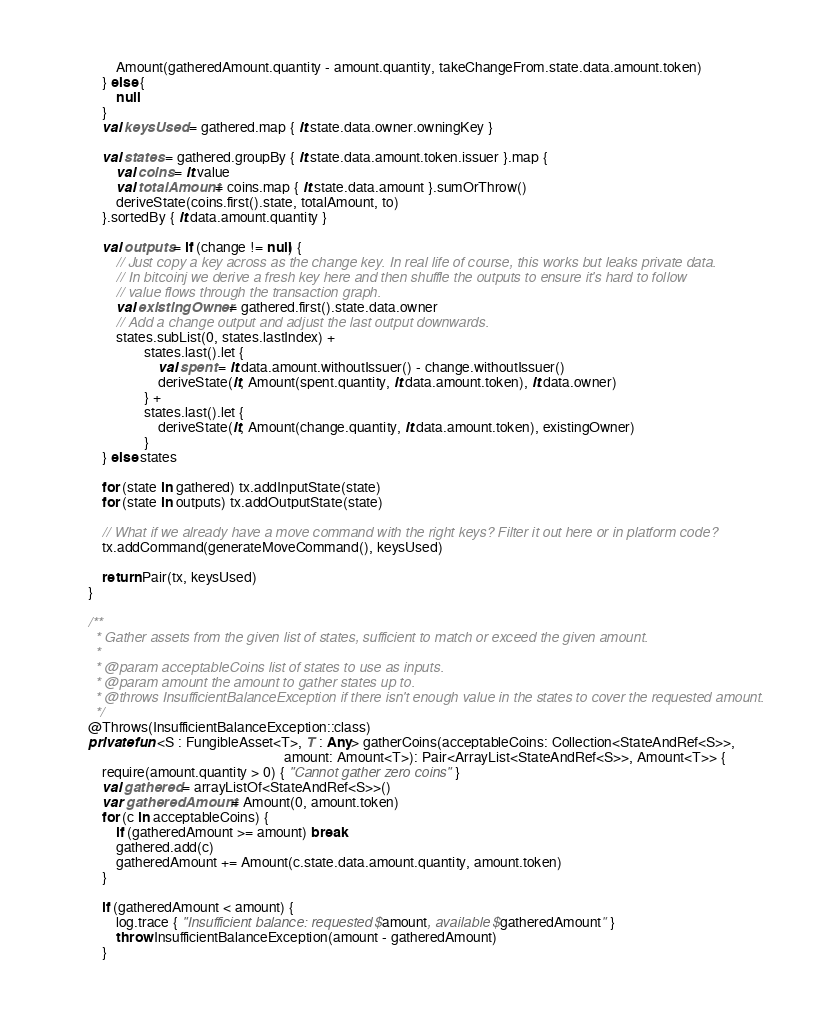<code> <loc_0><loc_0><loc_500><loc_500><_Kotlin_>                Amount(gatheredAmount.quantity - amount.quantity, takeChangeFrom.state.data.amount.token)
            } else {
                null
            }
            val keysUsed = gathered.map { it.state.data.owner.owningKey }

            val states = gathered.groupBy { it.state.data.amount.token.issuer }.map {
                val coins = it.value
                val totalAmount = coins.map { it.state.data.amount }.sumOrThrow()
                deriveState(coins.first().state, totalAmount, to)
            }.sortedBy { it.data.amount.quantity }

            val outputs = if (change != null) {
                // Just copy a key across as the change key. In real life of course, this works but leaks private data.
                // In bitcoinj we derive a fresh key here and then shuffle the outputs to ensure it's hard to follow
                // value flows through the transaction graph.
                val existingOwner = gathered.first().state.data.owner
                // Add a change output and adjust the last output downwards.
                states.subList(0, states.lastIndex) +
                        states.last().let {
                            val spent = it.data.amount.withoutIssuer() - change.withoutIssuer()
                            deriveState(it, Amount(spent.quantity, it.data.amount.token), it.data.owner)
                        } +
                        states.last().let {
                            deriveState(it, Amount(change.quantity, it.data.amount.token), existingOwner)
                        }
            } else states

            for (state in gathered) tx.addInputState(state)
            for (state in outputs) tx.addOutputState(state)

            // What if we already have a move command with the right keys? Filter it out here or in platform code?
            tx.addCommand(generateMoveCommand(), keysUsed)

            return Pair(tx, keysUsed)
        }

        /**
         * Gather assets from the given list of states, sufficient to match or exceed the given amount.
         *
         * @param acceptableCoins list of states to use as inputs.
         * @param amount the amount to gather states up to.
         * @throws InsufficientBalanceException if there isn't enough value in the states to cover the requested amount.
         */
        @Throws(InsufficientBalanceException::class)
        private fun <S : FungibleAsset<T>, T : Any> gatherCoins(acceptableCoins: Collection<StateAndRef<S>>,
                                                                amount: Amount<T>): Pair<ArrayList<StateAndRef<S>>, Amount<T>> {
            require(amount.quantity > 0) { "Cannot gather zero coins" }
            val gathered = arrayListOf<StateAndRef<S>>()
            var gatheredAmount = Amount(0, amount.token)
            for (c in acceptableCoins) {
                if (gatheredAmount >= amount) break
                gathered.add(c)
                gatheredAmount += Amount(c.state.data.amount.quantity, amount.token)
            }

            if (gatheredAmount < amount) {
                log.trace { "Insufficient balance: requested $amount, available $gatheredAmount" }
                throw InsufficientBalanceException(amount - gatheredAmount)
            }
</code> 